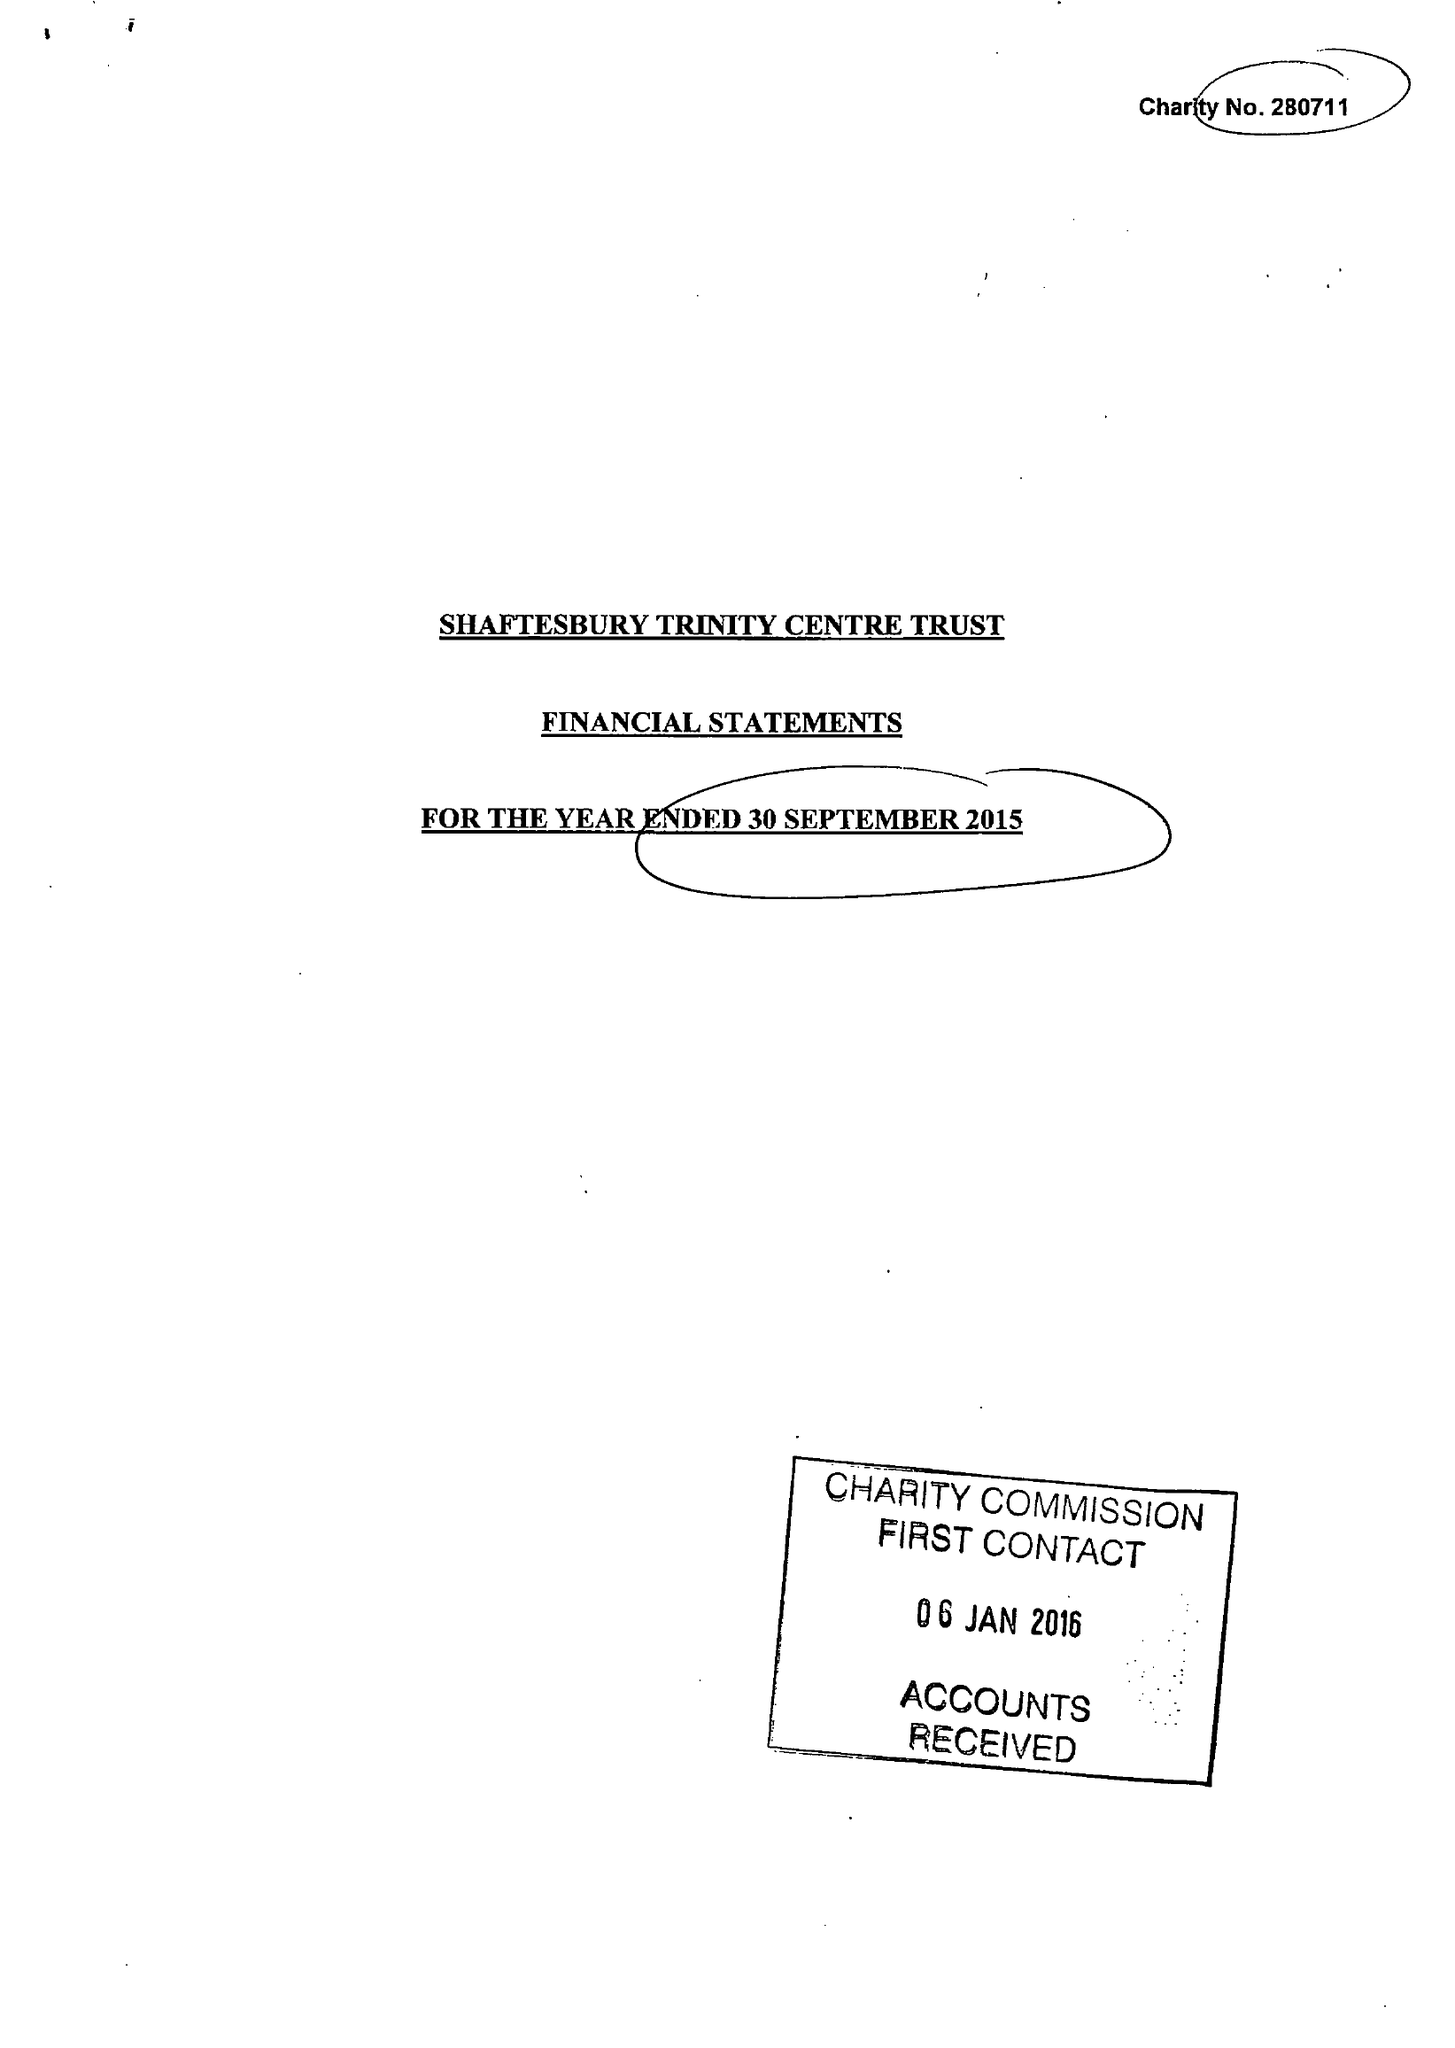What is the value for the address__street_line?
Answer the question using a single word or phrase. None 